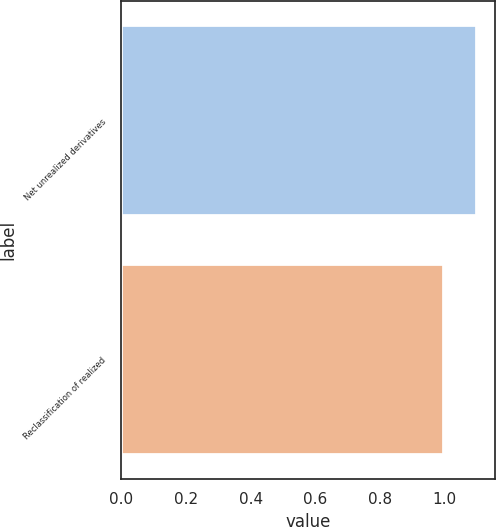Convert chart. <chart><loc_0><loc_0><loc_500><loc_500><bar_chart><fcel>Net unrealized derivatives<fcel>Reclassification of realized<nl><fcel>1.1<fcel>1<nl></chart> 